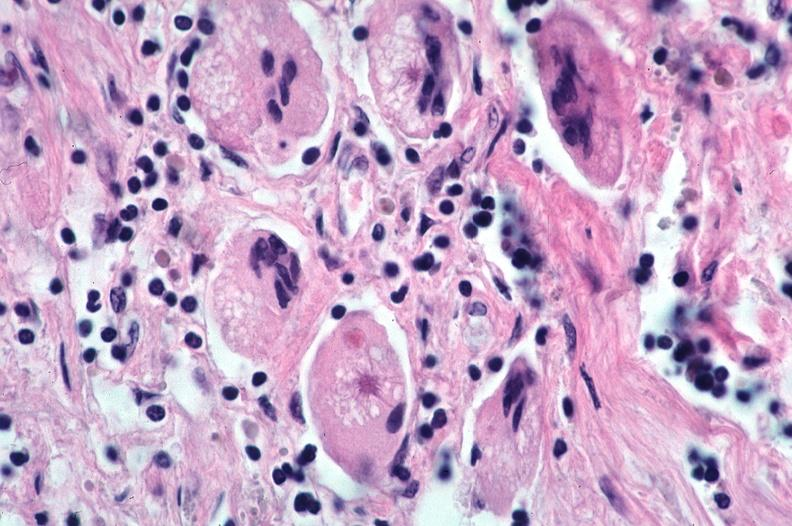s respiratory present?
Answer the question using a single word or phrase. Yes 